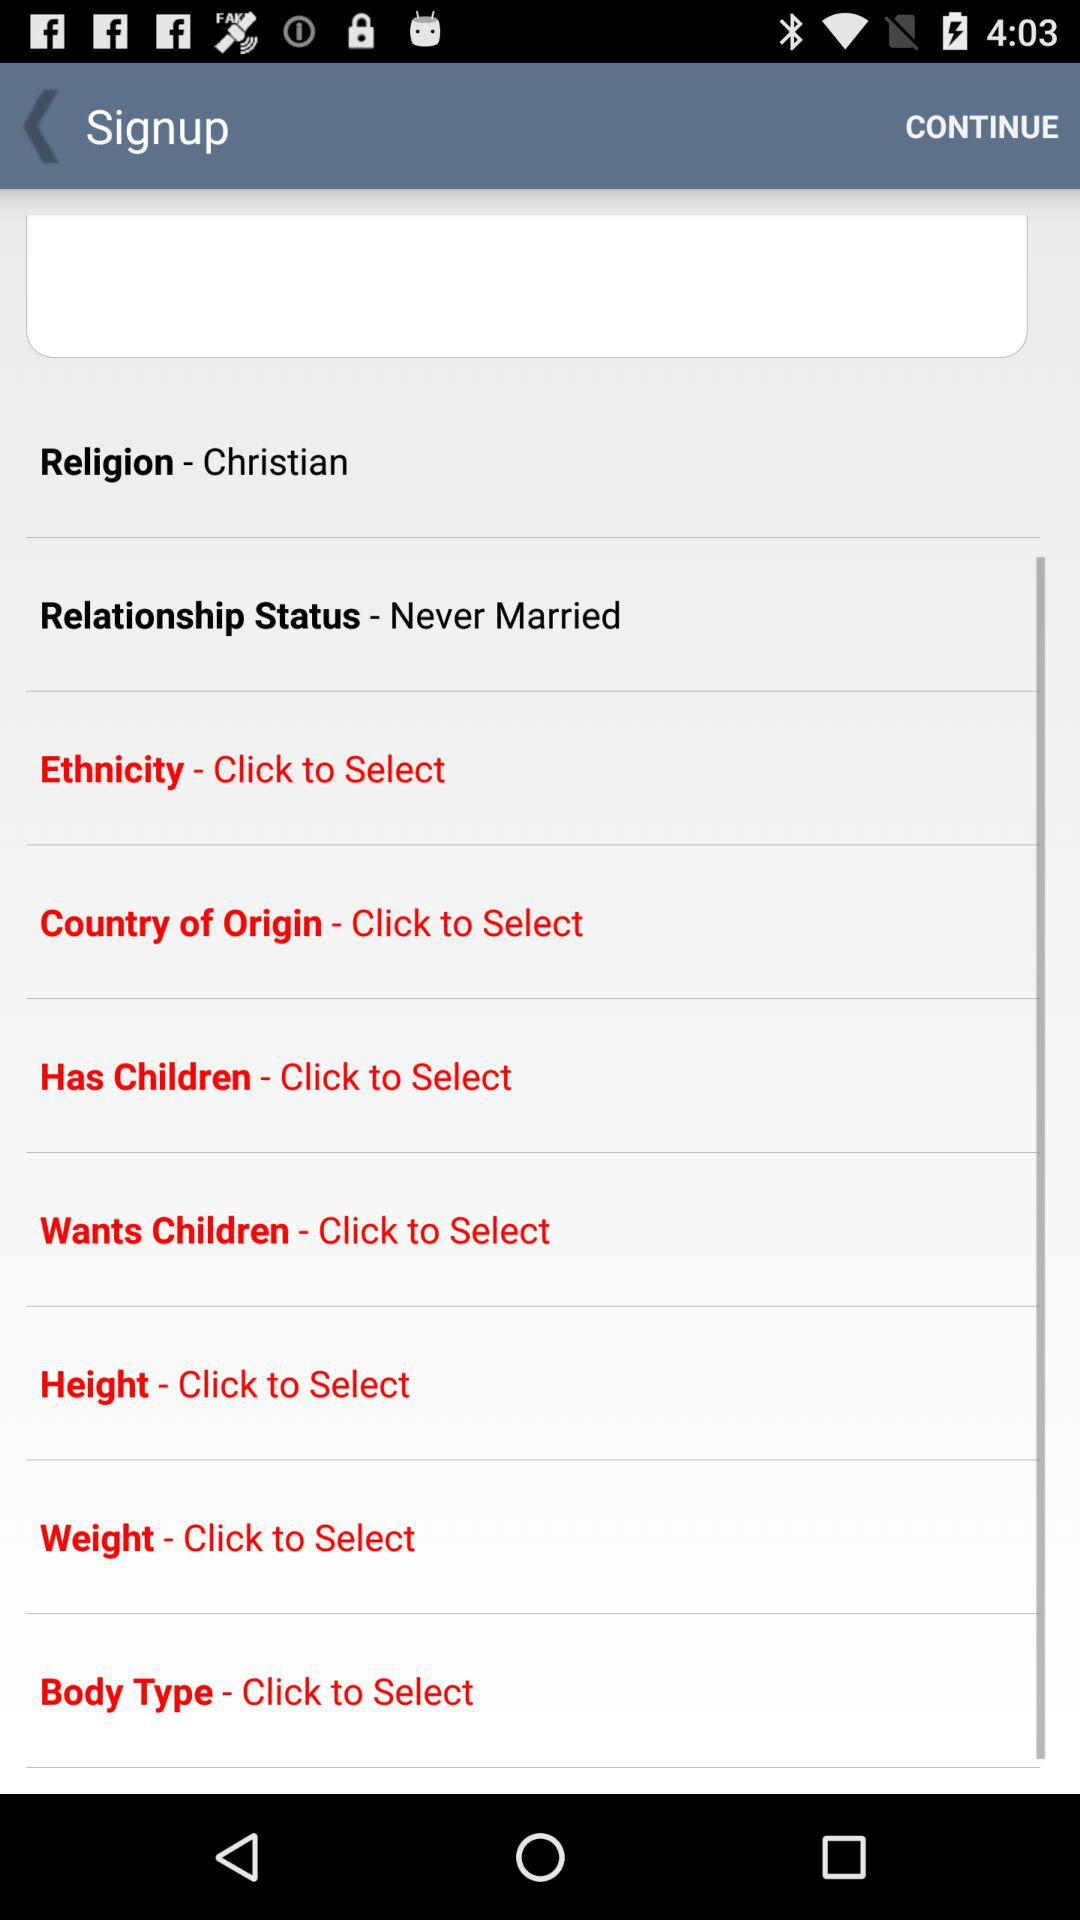What is the relationship status? The relationship status is "Never Married". 